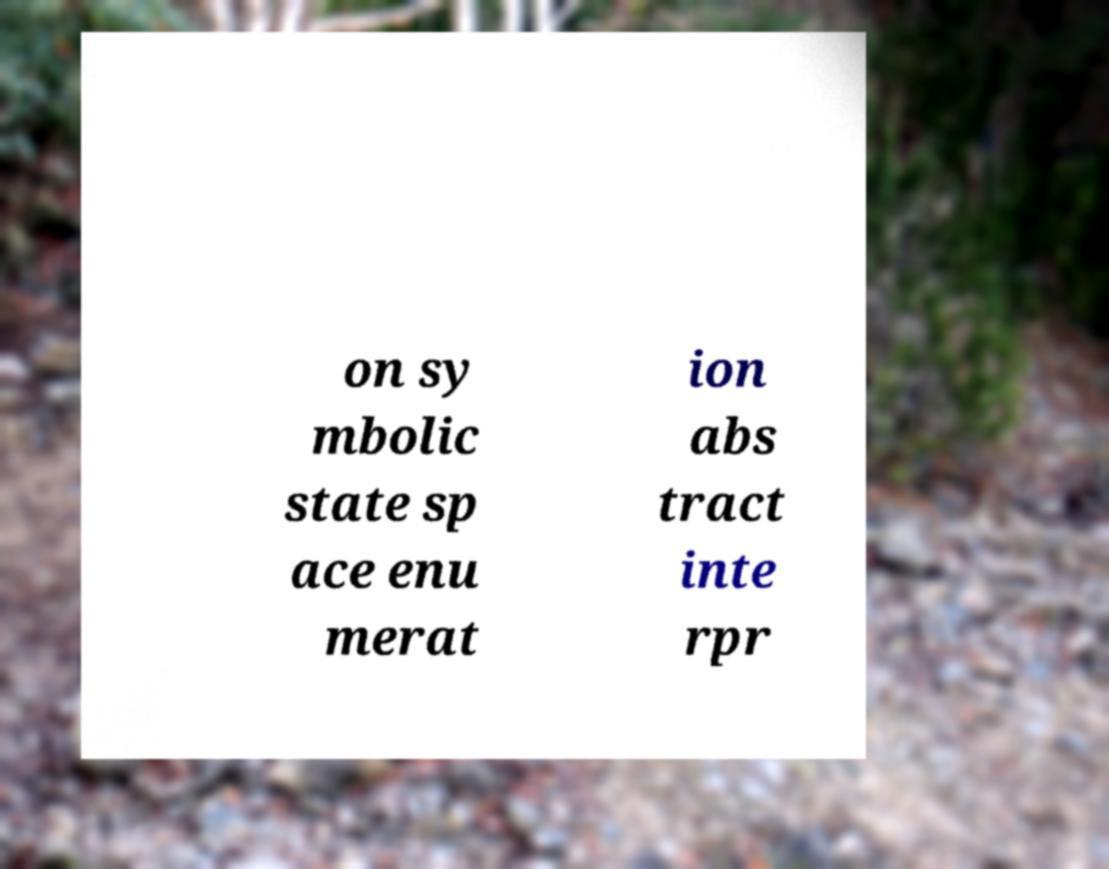Could you extract and type out the text from this image? on sy mbolic state sp ace enu merat ion abs tract inte rpr 